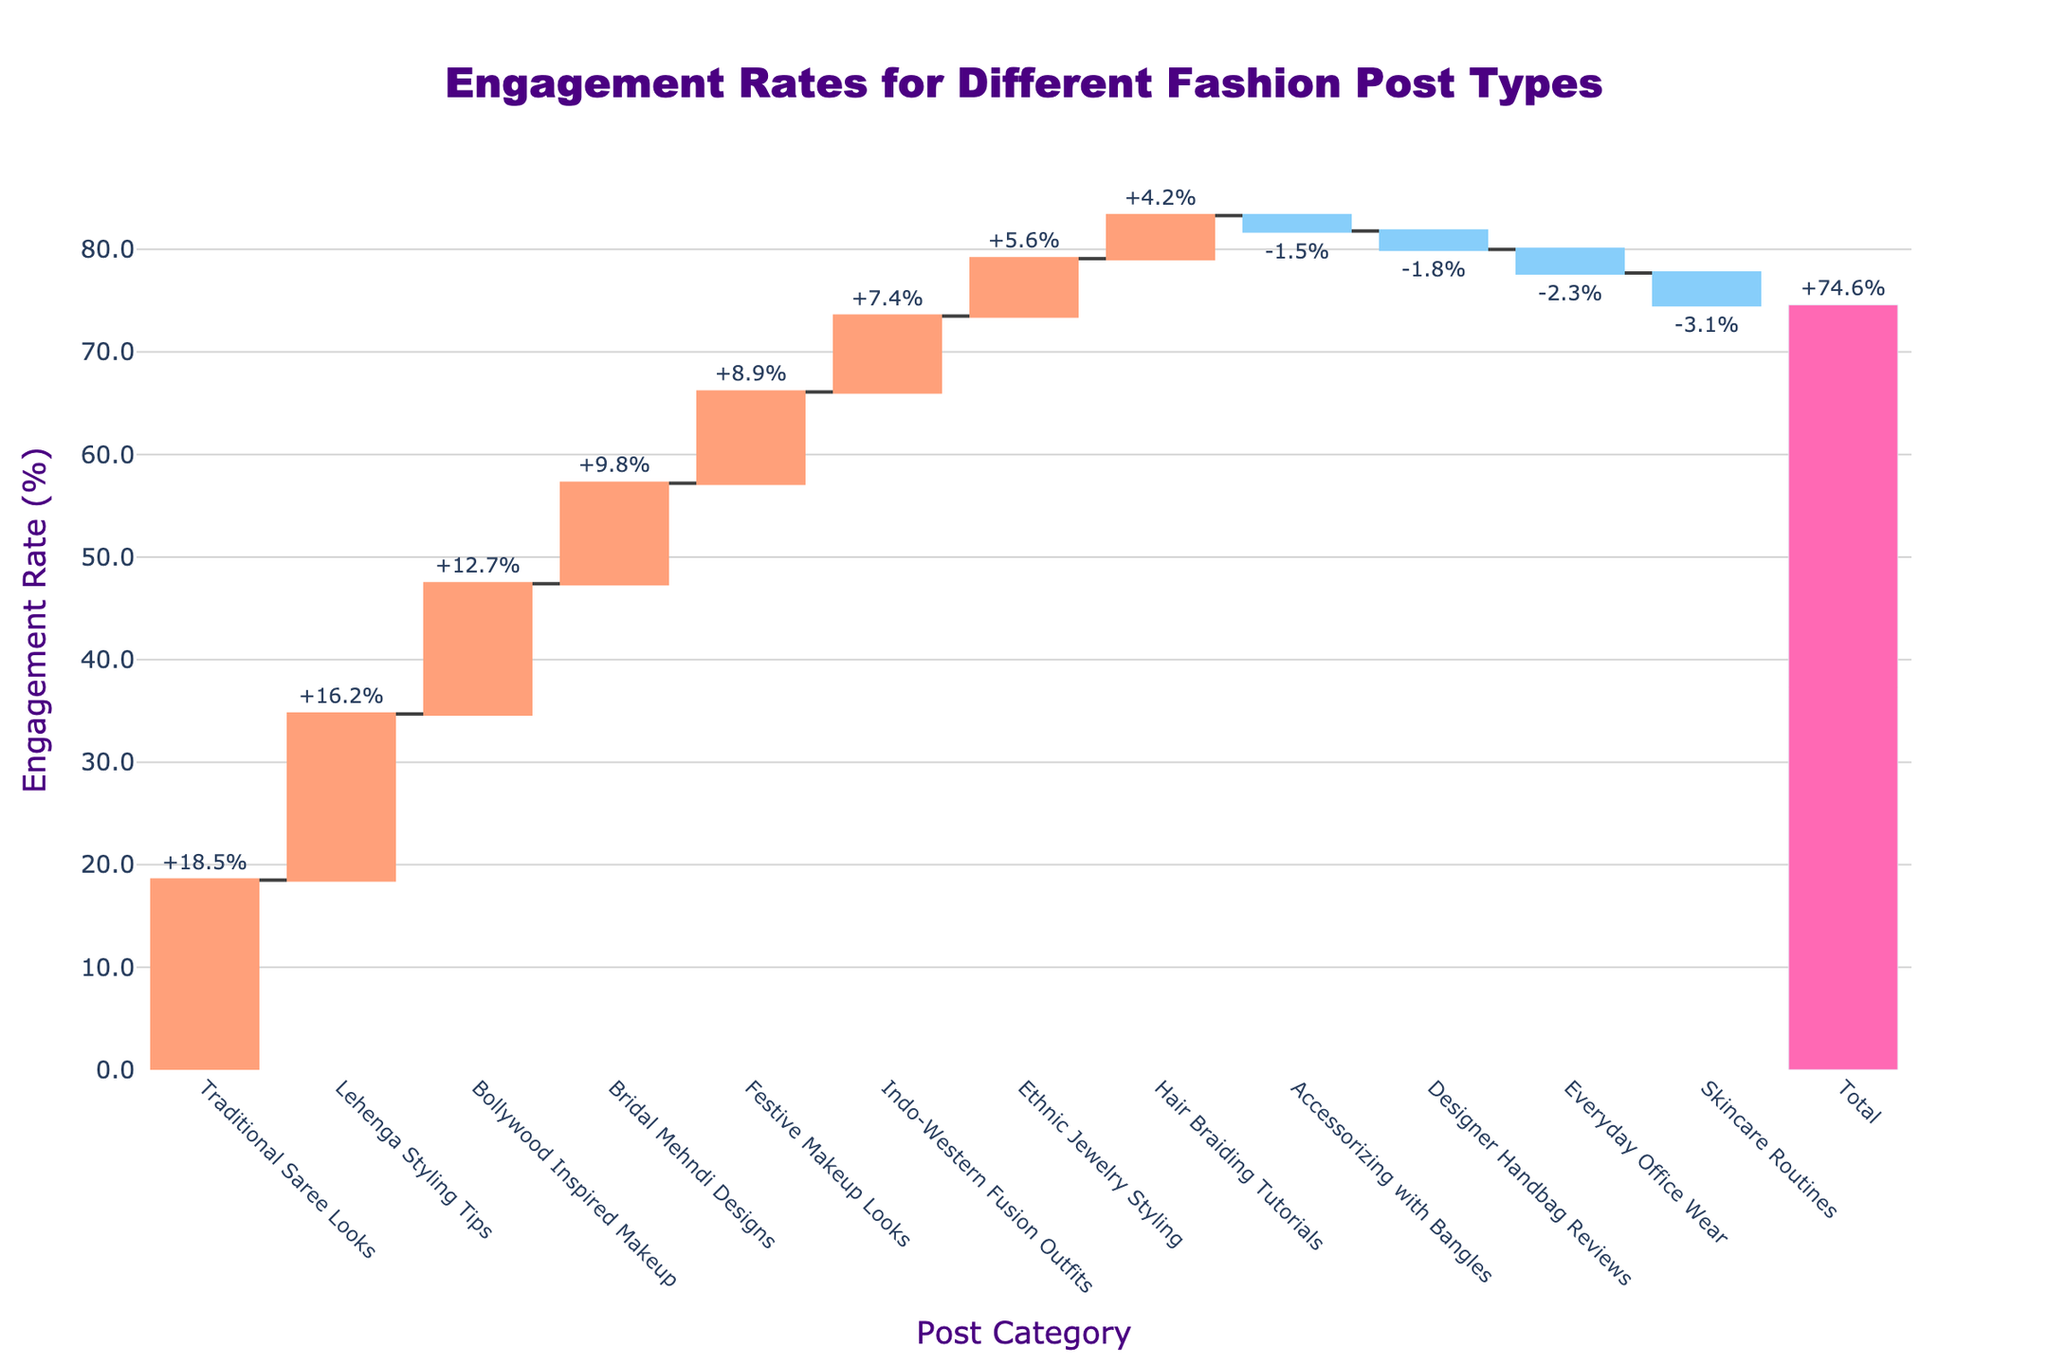What's the title of the chart? The title is typically displayed at the top of the chart. For this figure, it is clearly labeled as "Engagement Rates for Different Fashion Post Types".
Answer: Engagement Rates for Different Fashion Post Types How many categories of fashion posts are represented in the chart? Each category is listed along the x-axis. Counting them provides the number of categories. There are 12 categories presented.
Answer: 12 Which type of post has the highest engagement rate? By examining the tallest bar, which is colored distinctively (often with a different color for increasing values), you will find "Traditional Saree Looks" at 18.5%.
Answer: Traditional Saree Looks How does the engagement rate of "Ethnic Jewelry Styling" compare to "Festive Makeup Looks"? Locate both categories on the x-axis and compare their corresponding bars. "Ethnic Jewelry Styling" has an engagement rate of 5.6%, while "Festive Makeup Looks" has 8.9%.
Answer: Festive Makeup Looks has a higher engagement rate What's the total engagement rate across all post types? Analyzing the pink bar labeled "Total" reveals its position and associated value. The total engagement rate sums up to 74.4%.
Answer: 74.4% Which category has the lowest engagement rate? Identify the shortest bar among those representing negative rates, often highlighted differently, finding "Skincare Routines" at -3.1%.
Answer: Skincare Routines What is the difference in engagement rate between "Traditional Saree Looks" and "Lehenga Styling Tips"? Subtract the engagement rate of "Lehenga Styling Tips" (16.2%) from "Traditional Saree Looks" (18.5%). This results in 18.5 - 16.2 = 2.3%.
Answer: 2.3% How many post categories have negative engagement rates? Count all the bars below the zero line. There are 4 categories: “Everyday Office Wear", "Accessorizing with Bangles", "Skincare Routines", and "Designer Handbag Reviews”.
Answer: 4 What's the average engagement rate for categories with a negative engagement rate? Sum the engagement rates of all negative categories and divide by the number of categories: (-2.3) + (-1.5) + (-3.1) + (-1.8) = -8.7, then -8.7 / 4 = -2.175%.
Answer: -2.175% Which has a higher engagement rate: "Bridal Mehndi Designs" or "Indo-Western Fusion Outfits"? Compare the heights and values of their bars. "Bridal Mehndi Designs" is 9.8%, and "Indo-Western Fusion Outfits" is 7.4%. Therefore, "Bridal Mehndi Designs" has a higher engagement rate.
Answer: Bridal Mehndi Designs 